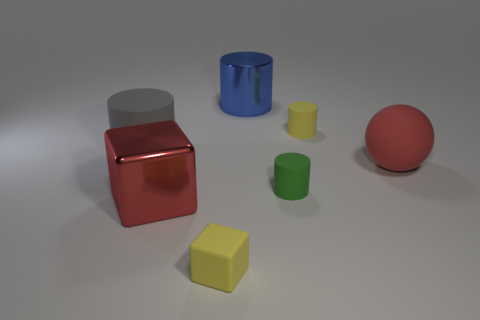What number of cyan rubber objects are the same shape as the big gray matte object?
Ensure brevity in your answer.  0. Does the blue cylinder have the same material as the big cylinder left of the large blue shiny cylinder?
Your answer should be very brief. No. How many tiny rubber blocks are there?
Give a very brief answer. 1. What size is the block that is in front of the red metal thing?
Ensure brevity in your answer.  Small. What number of shiny things are the same size as the red matte thing?
Give a very brief answer. 2. What is the material of the large object that is on the right side of the big red metal thing and behind the rubber ball?
Offer a terse response. Metal. There is a blue cylinder that is the same size as the red metallic cube; what material is it?
Offer a very short reply. Metal. There is a shiny thing that is on the right side of the large red thing left of the matte object that is to the right of the small yellow cylinder; what is its size?
Your response must be concise. Large. What size is the yellow block that is made of the same material as the tiny yellow cylinder?
Make the answer very short. Small. There is a gray cylinder; is it the same size as the shiny thing in front of the gray rubber thing?
Offer a very short reply. Yes. 